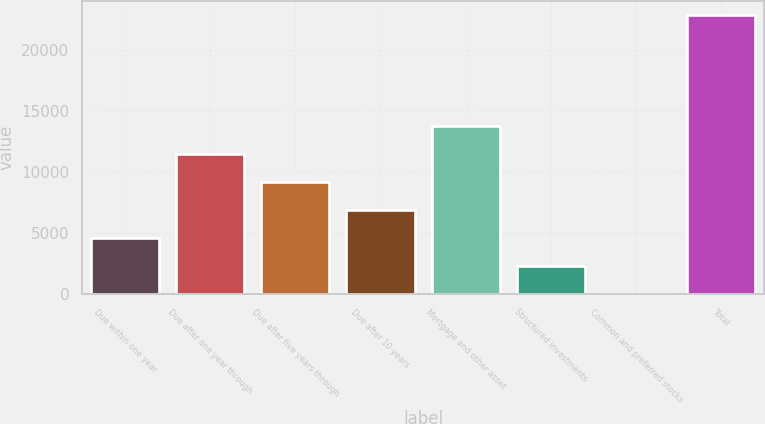<chart> <loc_0><loc_0><loc_500><loc_500><bar_chart><fcel>Due within one year<fcel>Due after one year through<fcel>Due after five years through<fcel>Due after 10 years<fcel>Mortgage and other asset<fcel>Structured investments<fcel>Common and preferred stocks<fcel>Total<nl><fcel>4604.2<fcel>11455<fcel>9171.4<fcel>6887.8<fcel>13738.6<fcel>2320.6<fcel>37<fcel>22873<nl></chart> 